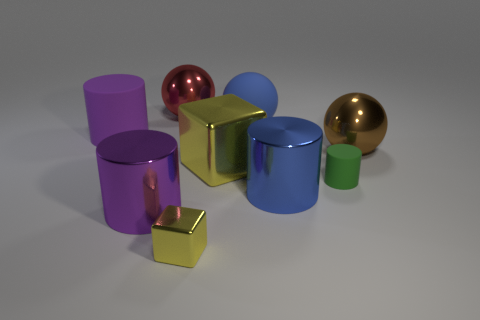Add 1 large green rubber blocks. How many objects exist? 10 Subtract all cylinders. How many objects are left? 5 Subtract all big purple things. Subtract all large matte objects. How many objects are left? 5 Add 9 large blue spheres. How many large blue spheres are left? 10 Add 3 big blue rubber things. How many big blue rubber things exist? 4 Subtract 0 brown blocks. How many objects are left? 9 